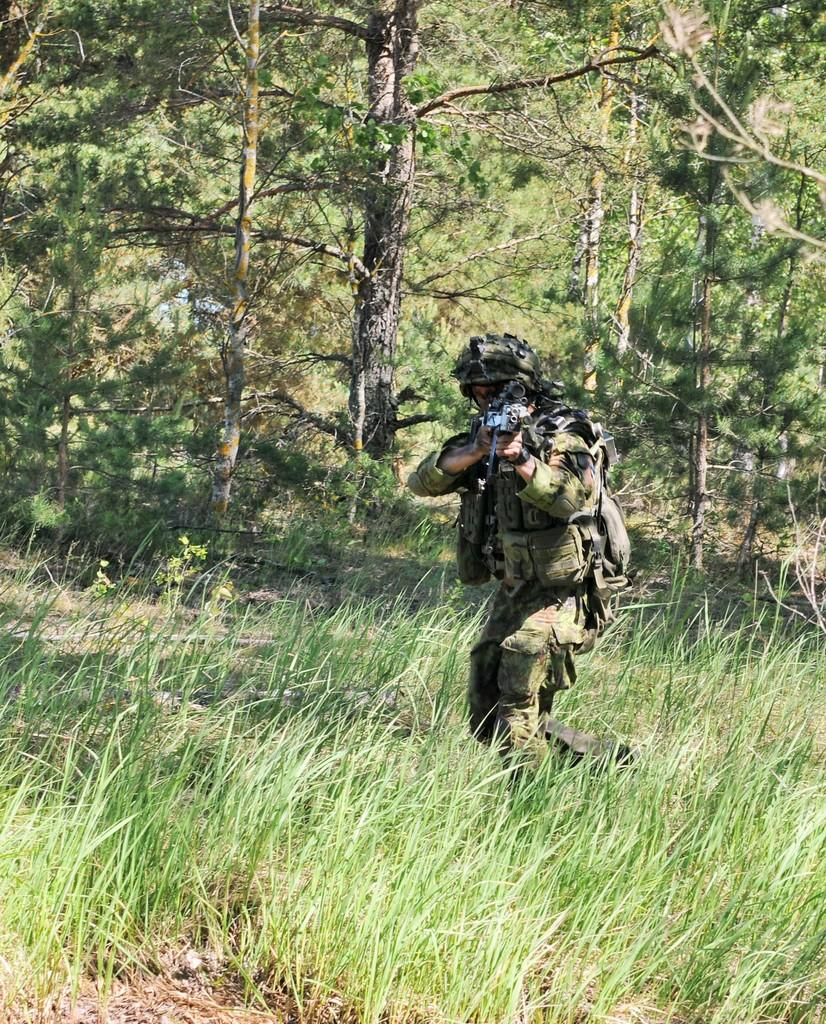What is the main subject of the image? There is a person standing in the center of the image. What is the person holding in the image? The person is holding a gun. What type of protective gear is the person wearing? The person is wearing a helmet. What can be seen in the background of the image? There are trees, plants, and grass in the background of the image. Can you tell me how many yaks are visible in the image? There are no yaks present in the image. What type of basketball shoes is the person wearing in the image? The person is not wearing any basketball shoes in the image; they are wearing a helmet. 